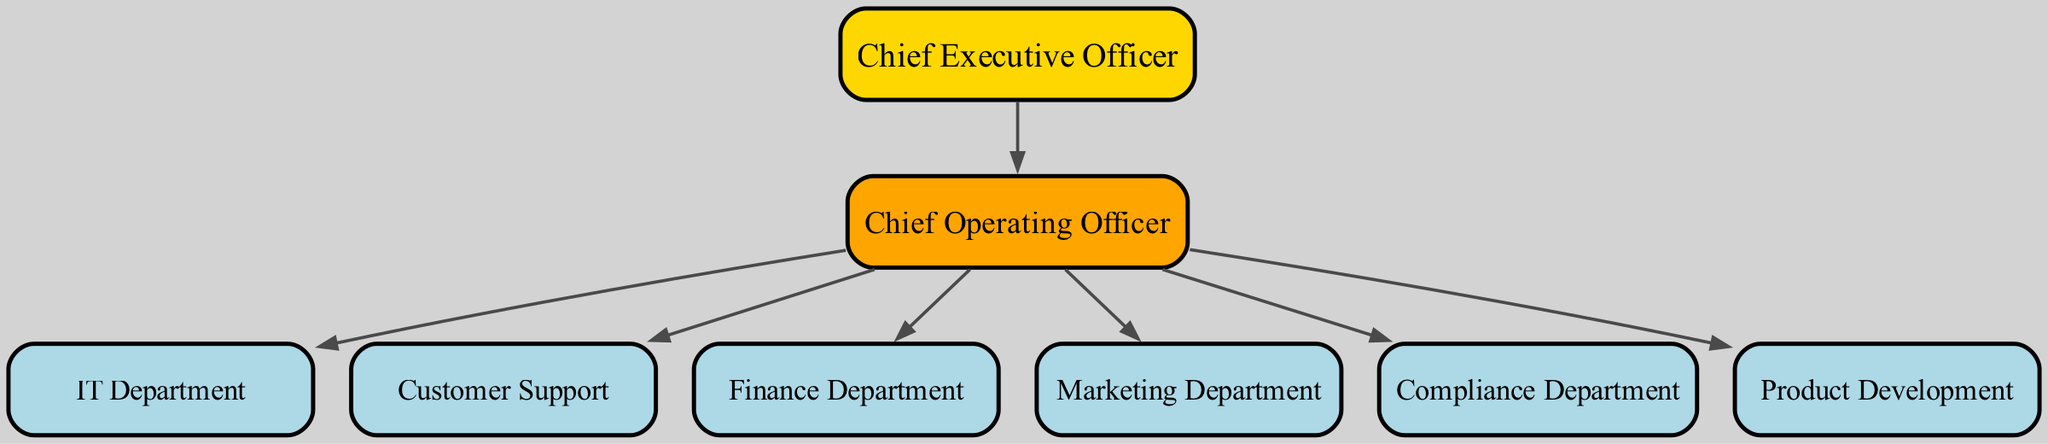What is the top position in the organizational structure? The top position in the diagram is represented by the node labeled "Chief Executive Officer", indicating its authority and the starting point of the reporting structure.
Answer: Chief Executive Officer How many departments report directly to the COO? By examining the edges connected to the COO, we find there are six departments listed that directly connect to this role: IT Department, Customer Support, Finance Department, Marketing Department, Compliance Department, and Product Development.
Answer: Six What color represents the CEO in the diagram? The CEO node is highlighted in gold, which is a distinct color used to denote its importance and leadership role within the organizational structure.
Answer: Gold Which department is responsible for handling customer inquiries? The Customer Support department is indicated in the diagram as the entity responsible for addressing queries and issues raised by users of the gambling platform.
Answer: Customer Support What is the relationship between the COO and the Compliance Department? The COO has a direct line (edge) leading to the Compliance Department, indicating that this department reports directly to the COO, aligning with operational oversight in regulatory matters.
Answer: Reports directly to Which department has the responsibility for financial matters? According to the diagram, the Finance Department is responsible for managing financial activities, indicated by its direct connection to the COO.
Answer: Finance Department If the CEO is at the top, who occupies the second level in the organization? The COO occupies the second level in the hierarchy, as its node is directly below the CEO's node, showing it as the primary executive responsible for operations.
Answer: Chief Operating Officer Are there any departments that do not report to the COO? No, all departments listed in the diagram have a direct reporting line to the COO, indicating that there are no departments outside of this oversight in the illustrated structure.
Answer: No 